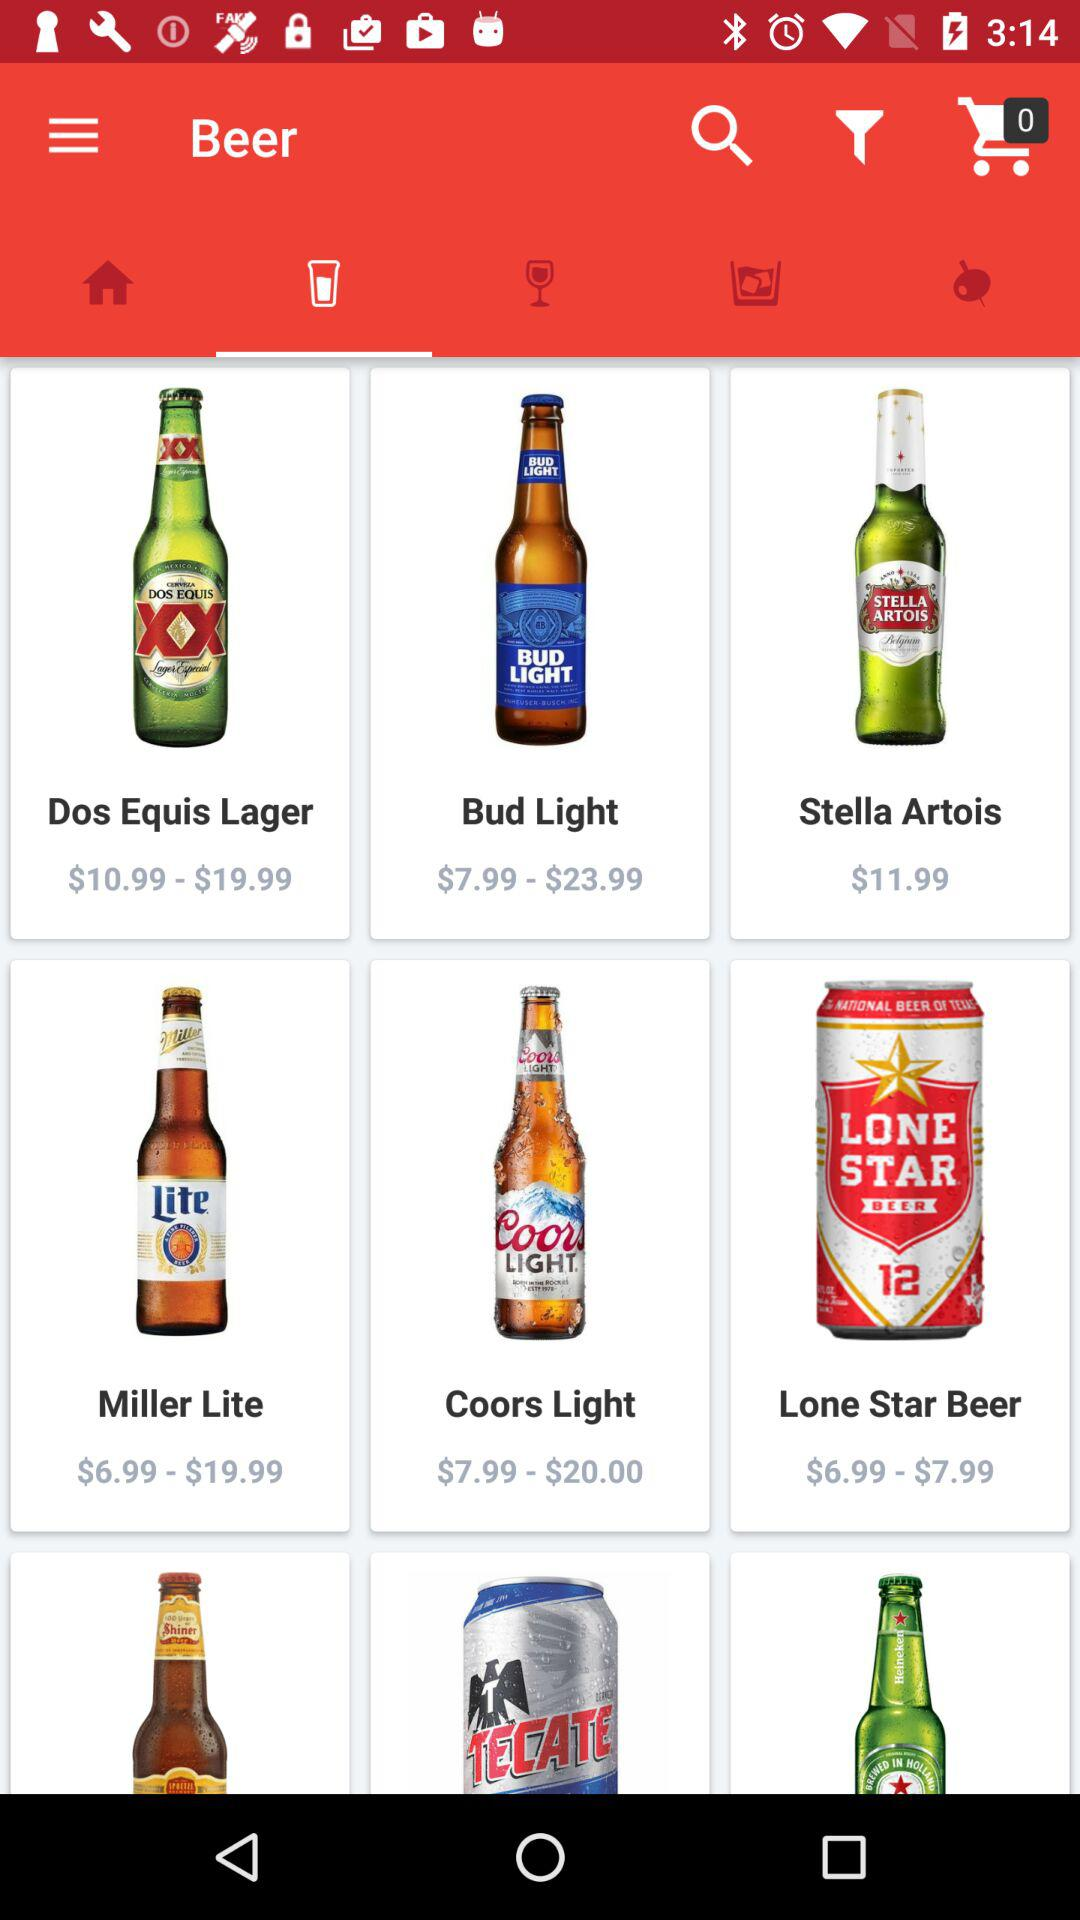Which tab has been selected? The tab that has been selected is "Beer". 